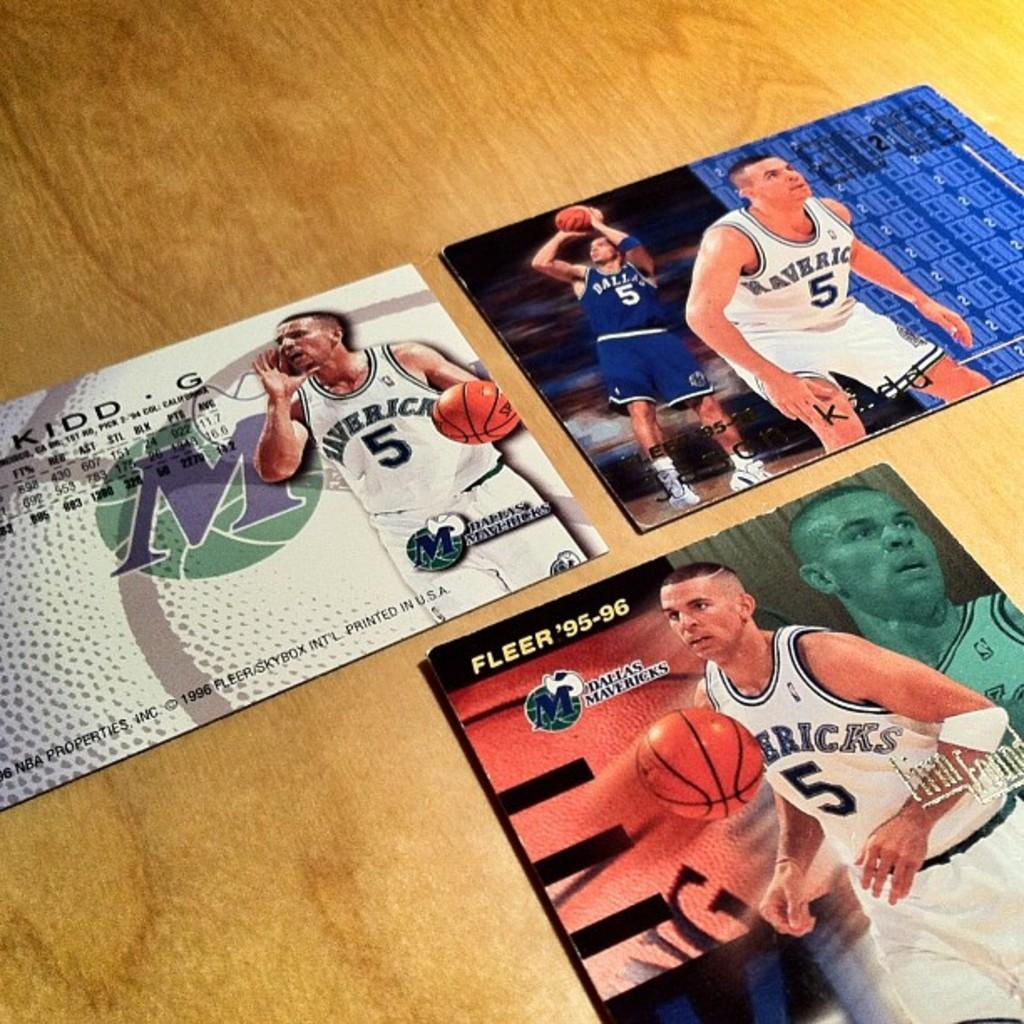What is placed on the wooden surface in the image? There are boards on the wooden surface in the image. What can be seen on the boards? There are photos of men on the boards, and there are balls in the photos. Is there any text on the boards? Yes, there is writing on the boards. Can you see any goats wearing skirts in the image? No, there are no goats or skirts present in the image. How many nails are used to attach the boards to the wooden surface? The provided facts do not mention the use of nails or any other fasteners, so we cannot determine the number of nails used. 